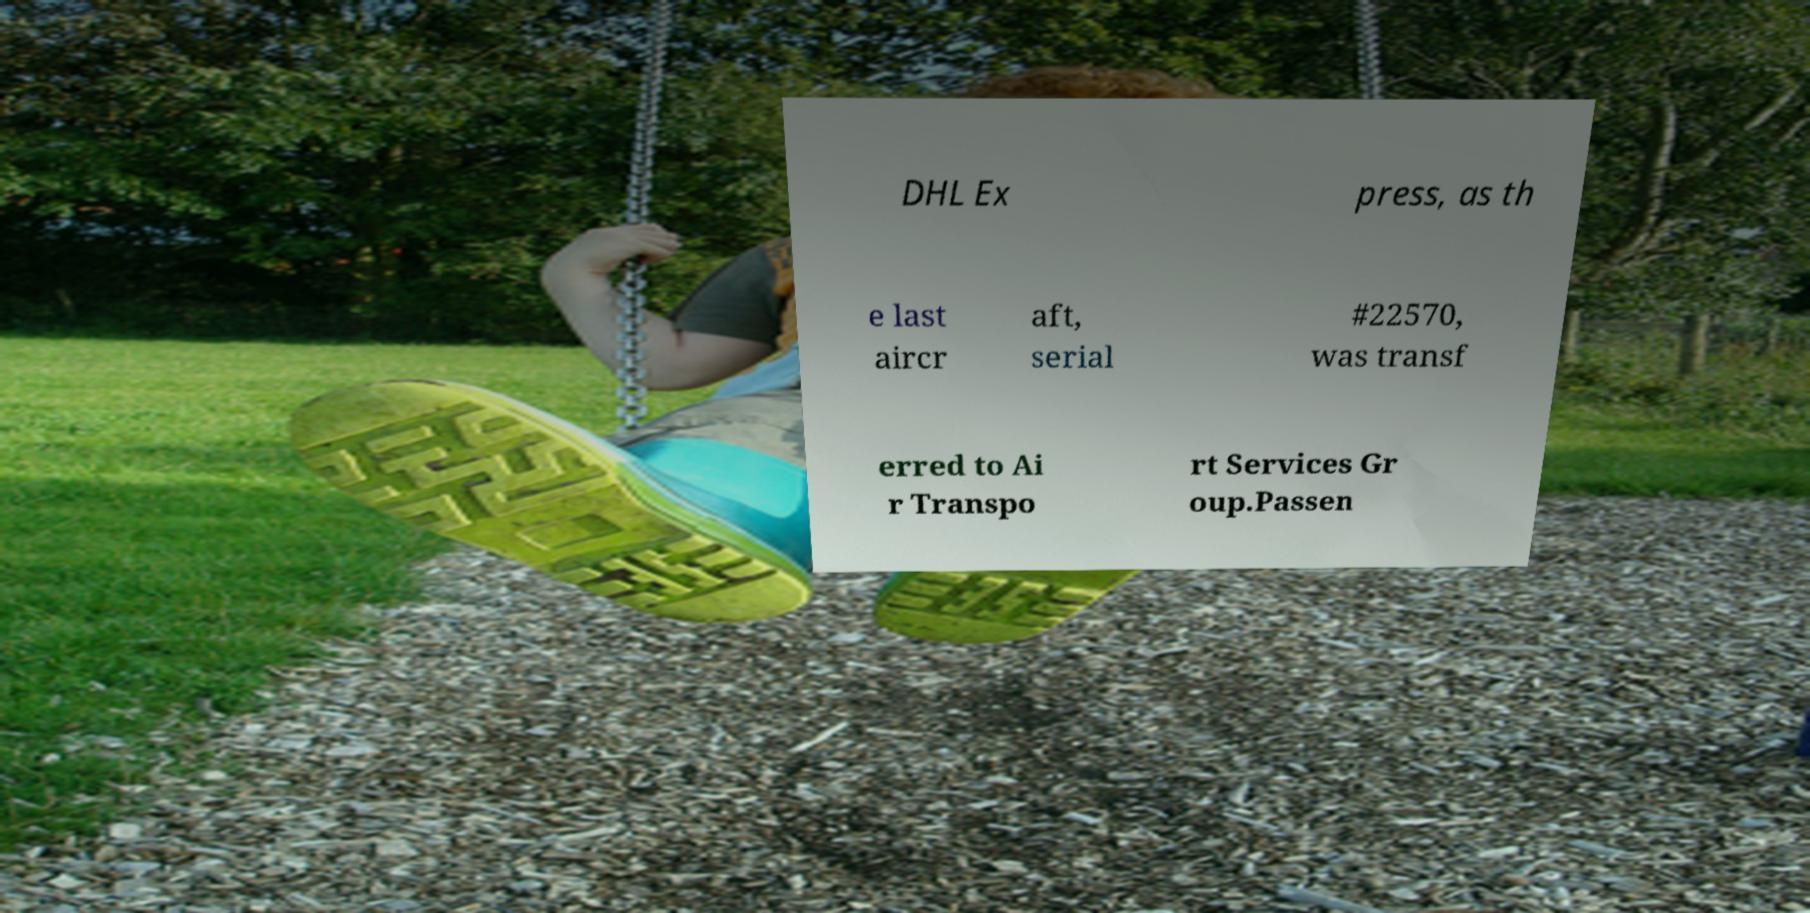Could you assist in decoding the text presented in this image and type it out clearly? DHL Ex press, as th e last aircr aft, serial #22570, was transf erred to Ai r Transpo rt Services Gr oup.Passen 